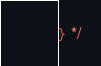Convert code to text. <code><loc_0><loc_0><loc_500><loc_500><_CSS_>} */
</code> 